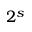Convert formula to latex. <formula><loc_0><loc_0><loc_500><loc_500>2 ^ { s }</formula> 